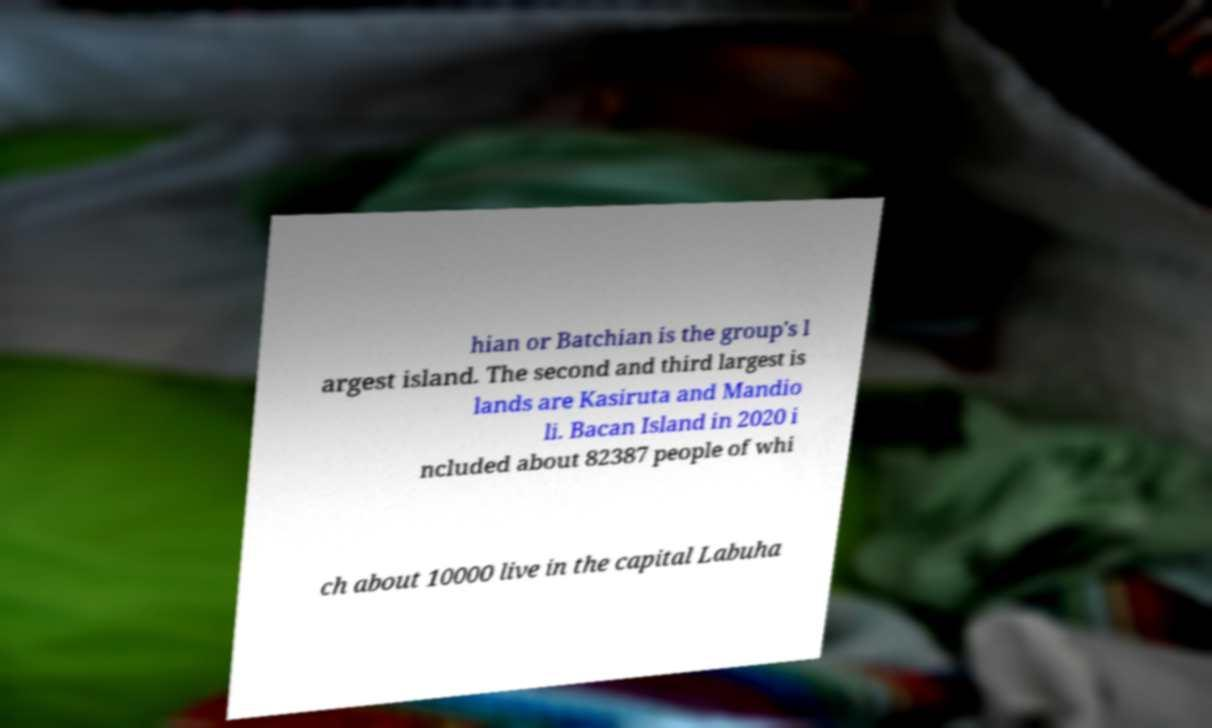Can you read and provide the text displayed in the image?This photo seems to have some interesting text. Can you extract and type it out for me? hian or Batchian is the group's l argest island. The second and third largest is lands are Kasiruta and Mandio li. Bacan Island in 2020 i ncluded about 82387 people of whi ch about 10000 live in the capital Labuha 